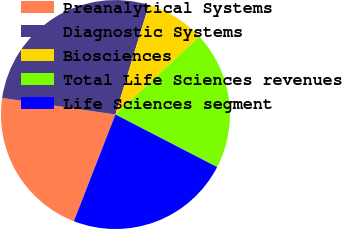Convert chart. <chart><loc_0><loc_0><loc_500><loc_500><pie_chart><fcel>Preanalytical Systems<fcel>Diagnostic Systems<fcel>Biosciences<fcel>Total Life Sciences revenues<fcel>Life Sciences segment<nl><fcel>21.41%<fcel>27.4%<fcel>8.36%<fcel>19.51%<fcel>23.32%<nl></chart> 